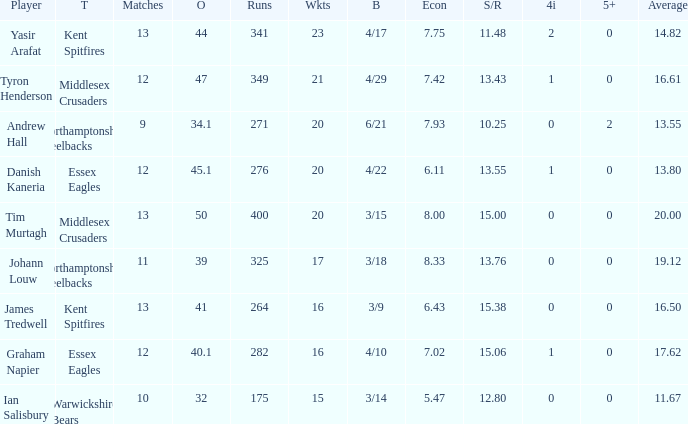Could you help me parse every detail presented in this table? {'header': ['Player', 'T', 'Matches', 'O', 'Runs', 'Wkts', 'B', 'Econ', 'S/R', '4i', '5+', 'Average'], 'rows': [['Yasir Arafat', 'Kent Spitfires', '13', '44', '341', '23', '4/17', '7.75', '11.48', '2', '0', '14.82'], ['Tyron Henderson', 'Middlesex Crusaders', '12', '47', '349', '21', '4/29', '7.42', '13.43', '1', '0', '16.61'], ['Andrew Hall', 'Northamptonshire Steelbacks', '9', '34.1', '271', '20', '6/21', '7.93', '10.25', '0', '2', '13.55'], ['Danish Kaneria', 'Essex Eagles', '12', '45.1', '276', '20', '4/22', '6.11', '13.55', '1', '0', '13.80'], ['Tim Murtagh', 'Middlesex Crusaders', '13', '50', '400', '20', '3/15', '8.00', '15.00', '0', '0', '20.00'], ['Johann Louw', 'Northamptonshire Steelbacks', '11', '39', '325', '17', '3/18', '8.33', '13.76', '0', '0', '19.12'], ['James Tredwell', 'Kent Spitfires', '13', '41', '264', '16', '3/9', '6.43', '15.38', '0', '0', '16.50'], ['Graham Napier', 'Essex Eagles', '12', '40.1', '282', '16', '4/10', '7.02', '15.06', '1', '0', '17.62'], ['Ian Salisbury', 'Warwickshire Bears', '10', '32', '175', '15', '3/14', '5.47', '12.80', '0', '0', '11.67']]} Name the matches for wickets 17 11.0. 